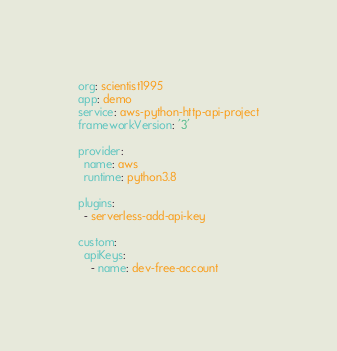<code> <loc_0><loc_0><loc_500><loc_500><_YAML_>org: scientist1995
app: demo
service: aws-python-http-api-project
frameworkVersion: '3'

provider:
  name: aws
  runtime: python3.8

plugins:
  - serverless-add-api-key

custom:
  apiKeys:
    - name: dev-free-account</code> 